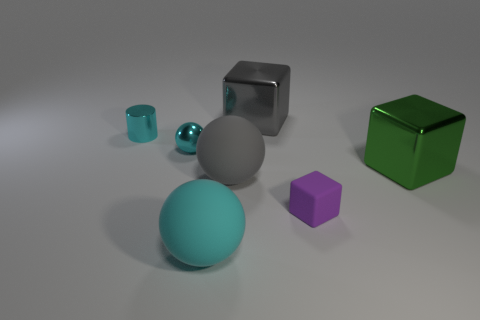Add 3 green things. How many objects exist? 10 Subtract all cubes. How many objects are left? 4 Add 5 tiny green spheres. How many tiny green spheres exist? 5 Subtract 1 cyan cylinders. How many objects are left? 6 Subtract all cylinders. Subtract all tiny purple rubber things. How many objects are left? 5 Add 7 rubber objects. How many rubber objects are left? 10 